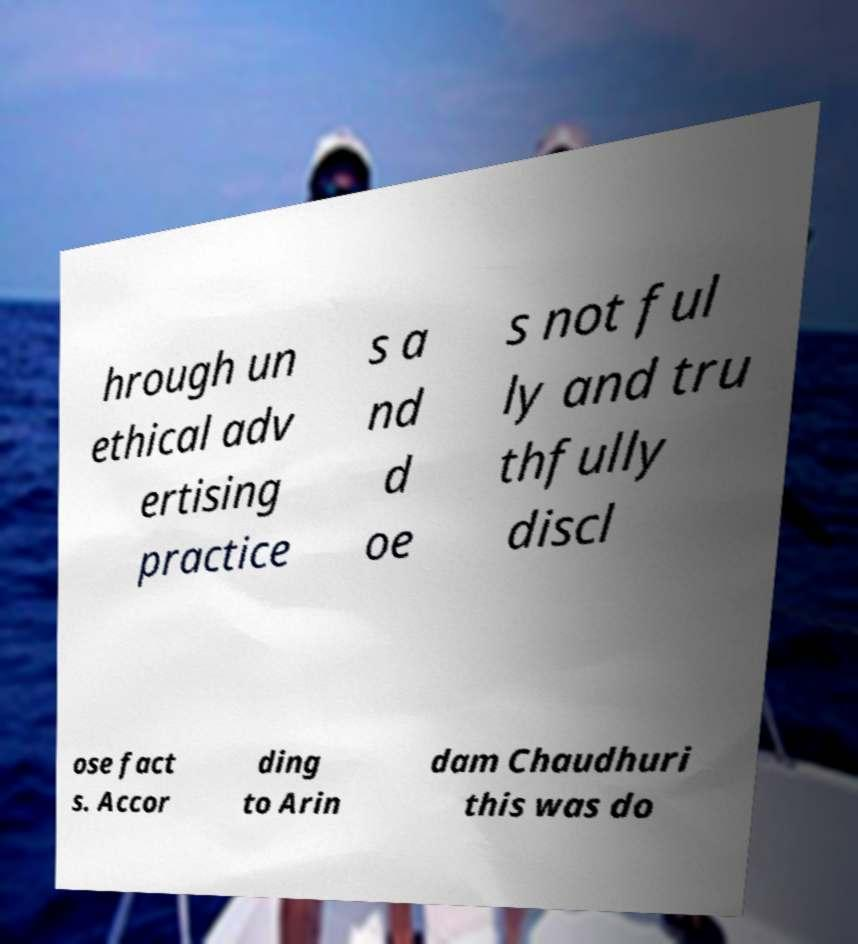I need the written content from this picture converted into text. Can you do that? hrough un ethical adv ertising practice s a nd d oe s not ful ly and tru thfully discl ose fact s. Accor ding to Arin dam Chaudhuri this was do 